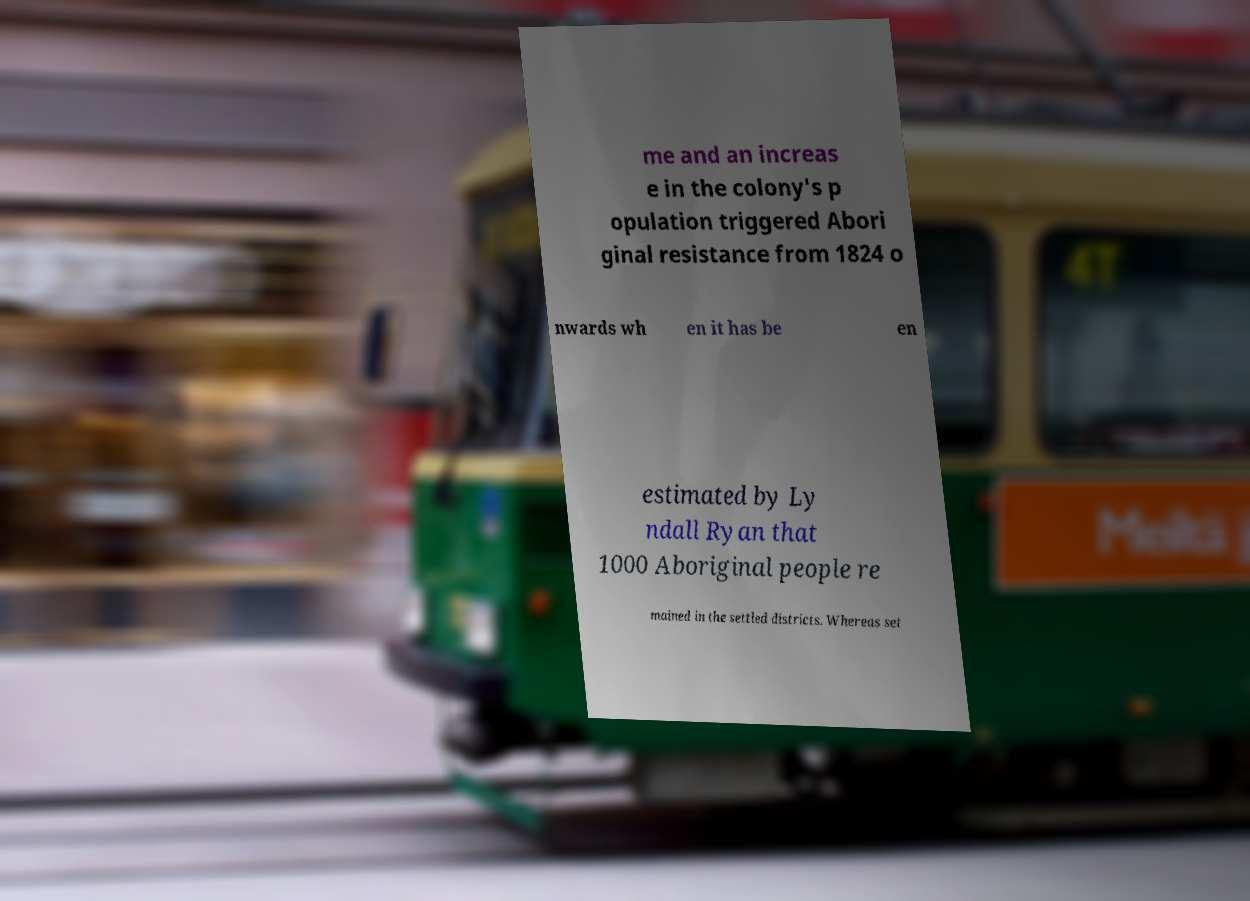Can you read and provide the text displayed in the image?This photo seems to have some interesting text. Can you extract and type it out for me? me and an increas e in the colony's p opulation triggered Abori ginal resistance from 1824 o nwards wh en it has be en estimated by Ly ndall Ryan that 1000 Aboriginal people re mained in the settled districts. Whereas set 